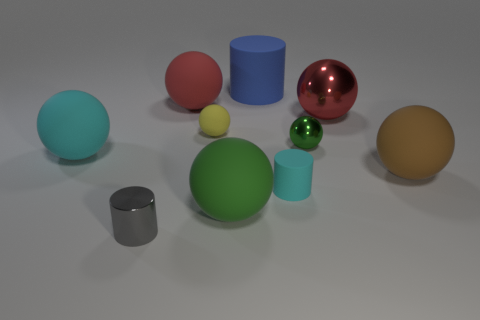What is the size of the rubber thing that is the same color as the tiny metal sphere?
Your response must be concise. Large. What number of large cyan rubber objects are behind the large matte sphere that is behind the large cyan object?
Provide a succinct answer. 0. What number of other things are there of the same material as the yellow object
Your response must be concise. 6. Do the green sphere in front of the big brown ball and the big red sphere left of the big metal thing have the same material?
Provide a succinct answer. Yes. Are there any other things that are the same shape as the blue object?
Make the answer very short. Yes. Does the large green ball have the same material as the large red sphere on the left side of the small yellow thing?
Your answer should be compact. Yes. The thing that is on the left side of the shiny object that is on the left side of the green sphere that is left of the small green sphere is what color?
Give a very brief answer. Cyan. There is a green rubber object that is the same size as the cyan sphere; what is its shape?
Your response must be concise. Sphere. Is there anything else that has the same size as the yellow thing?
Ensure brevity in your answer.  Yes. There is a green sphere to the left of the tiny cyan matte cylinder; is it the same size as the matte object behind the red matte thing?
Offer a very short reply. Yes. 